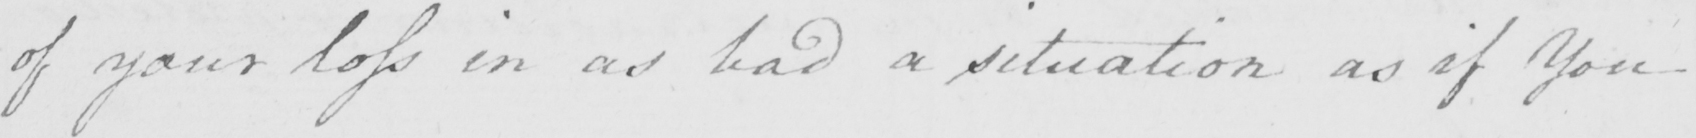Can you tell me what this handwritten text says? of your loss in as bad a situation as if You 